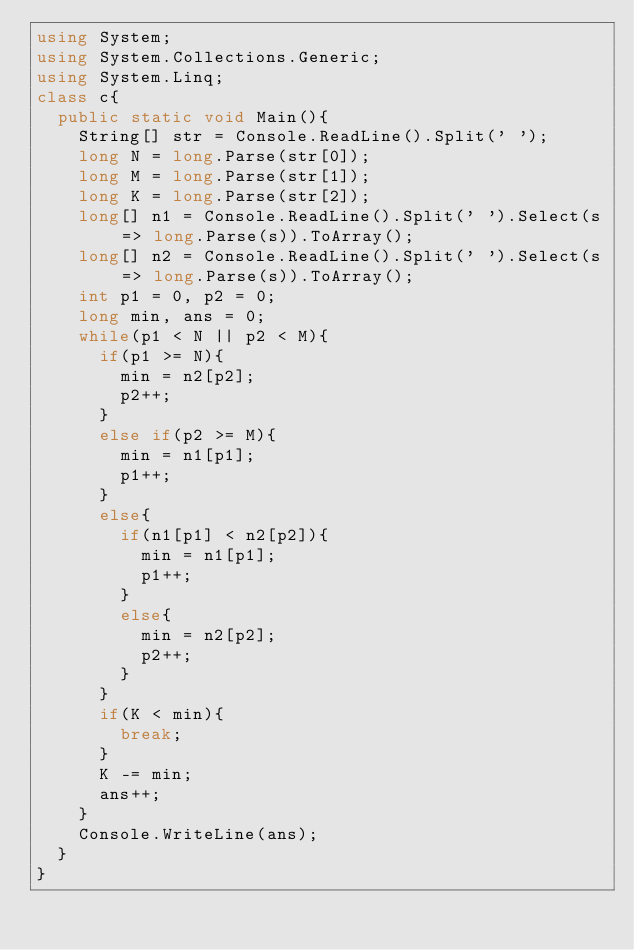Convert code to text. <code><loc_0><loc_0><loc_500><loc_500><_C#_>using System;
using System.Collections.Generic;
using System.Linq;
class c{
  public static void Main(){
    String[] str = Console.ReadLine().Split(' ');
    long N = long.Parse(str[0]);
    long M = long.Parse(str[1]);
    long K = long.Parse(str[2]);
    long[] n1 = Console.ReadLine().Split(' ').Select(s => long.Parse(s)).ToArray();
    long[] n2 = Console.ReadLine().Split(' ').Select(s => long.Parse(s)).ToArray();
    int p1 = 0, p2 = 0;
    long min, ans = 0;
    while(p1 < N || p2 < M){
      if(p1 >= N){
        min = n2[p2];
        p2++;
      }
      else if(p2 >= M){
        min = n1[p1];
        p1++;
      }
      else{
        if(n1[p1] < n2[p2]){
          min = n1[p1];
          p1++;
        }
        else{
          min = n2[p2];
          p2++;
        }
      }
      if(K < min){
        break;
      }
      K -= min;
      ans++;
    }
    Console.WriteLine(ans);
  }
}
</code> 